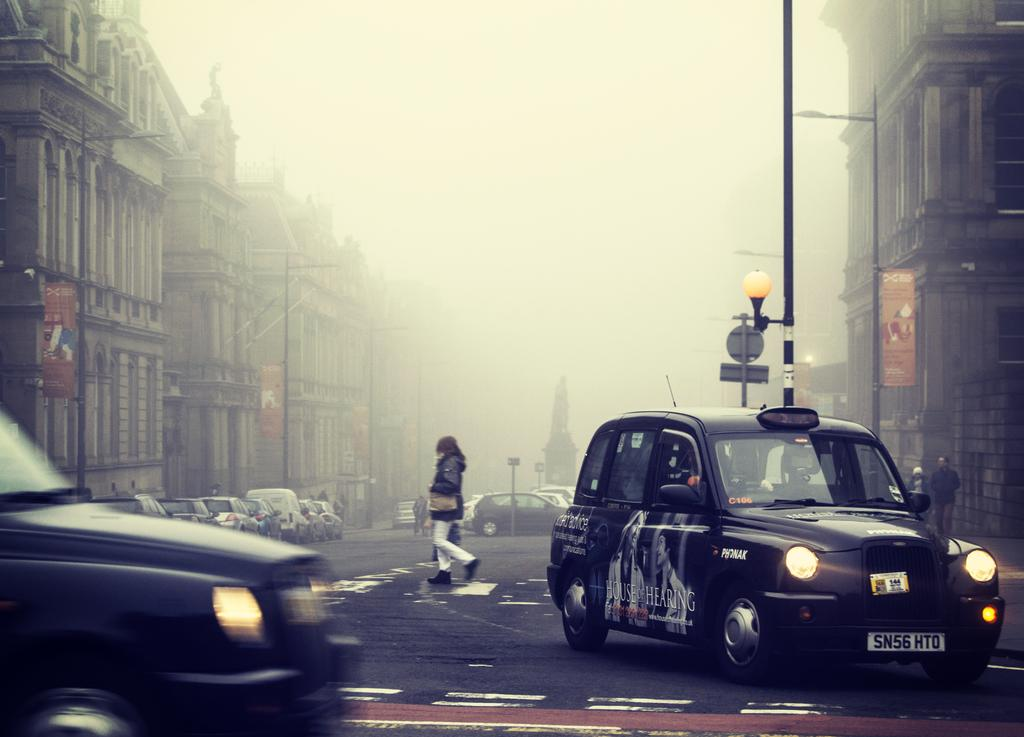What type of vehicles can be seen on the roads in the image? There are cars on the roads in the image. What are the people in the image doing? People are walking in the image. What structures are located beside the road in the image? There are buildings beside the road in the image. Can you see a trick being performed by someone wearing a dress in the image? There is no trick or person wearing a dress present in the image. What type of quiver is visible on the buildings in the image? There is no quiver present on the buildings in the image. 